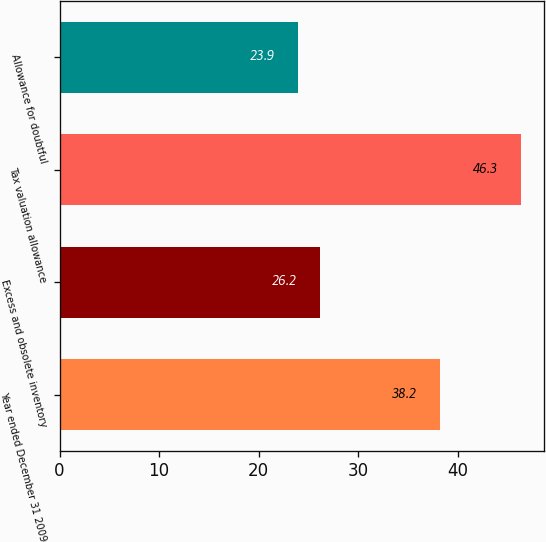Convert chart to OTSL. <chart><loc_0><loc_0><loc_500><loc_500><bar_chart><fcel>Year ended December 31 2009<fcel>Excess and obsolete inventory<fcel>Tax valuation allowance<fcel>Allowance for doubtful<nl><fcel>38.2<fcel>26.2<fcel>46.3<fcel>23.9<nl></chart> 